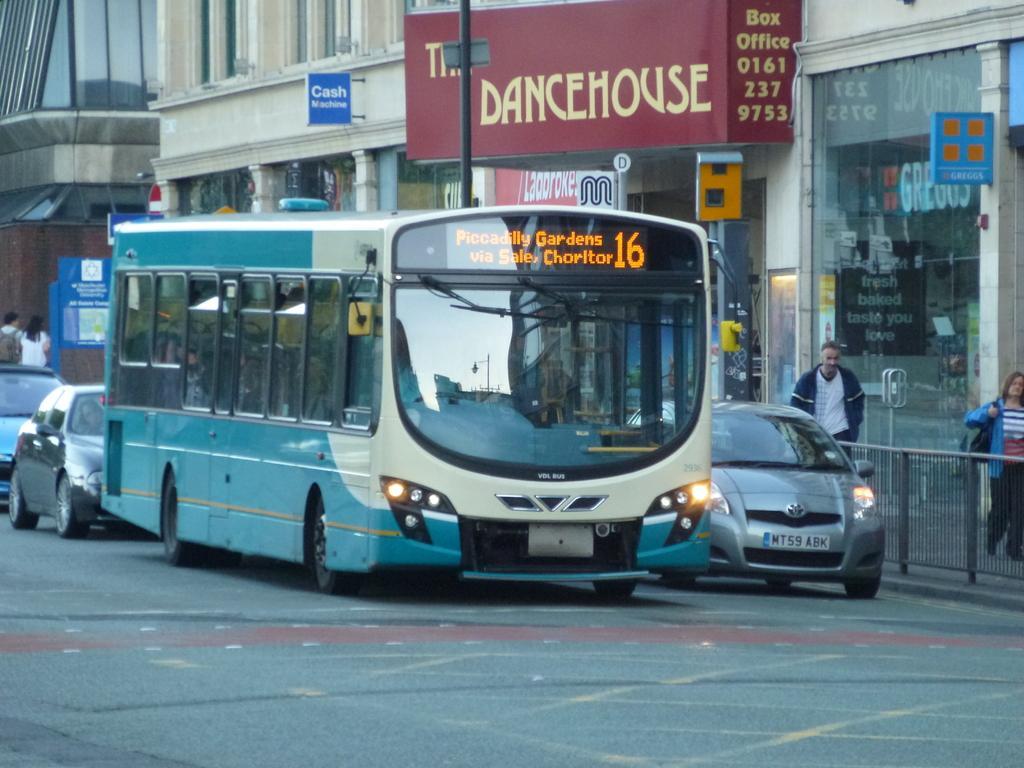Please provide a concise description of this image. In this image I can see few vehicles, few people walking, stalls, few boards and I can also see few buildings. 